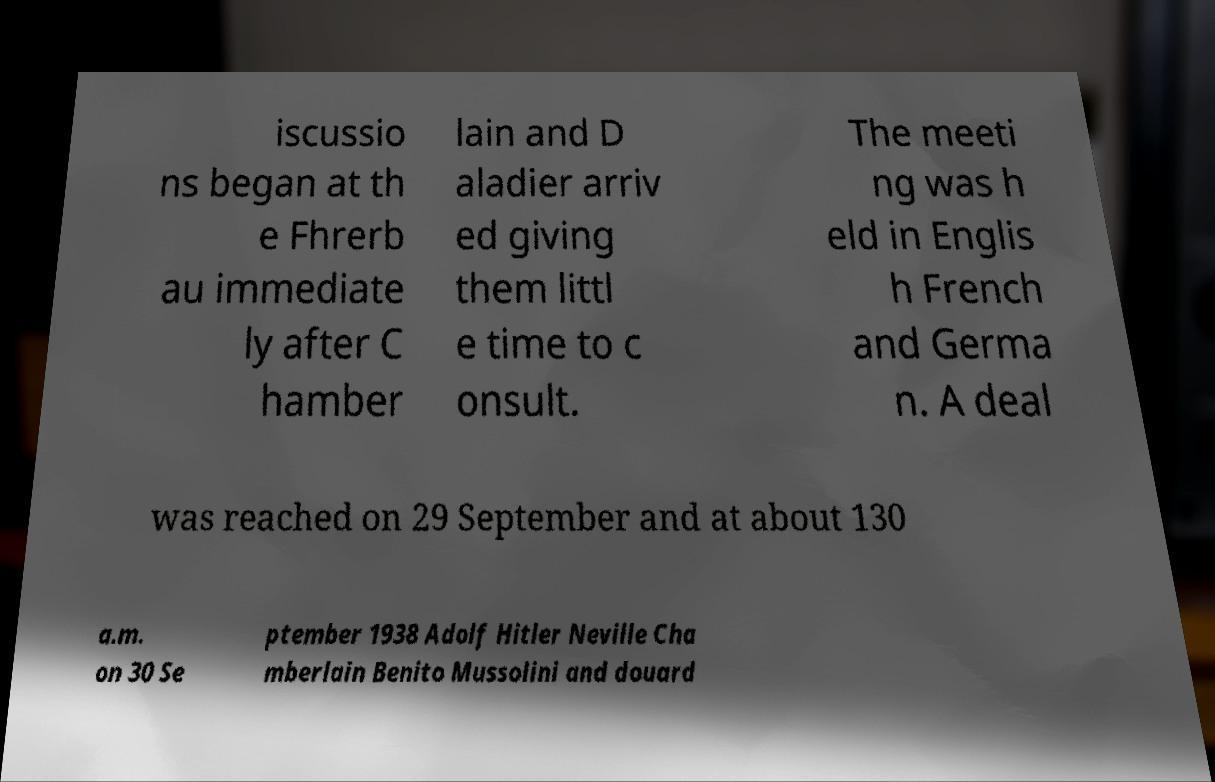Can you accurately transcribe the text from the provided image for me? iscussio ns began at th e Fhrerb au immediate ly after C hamber lain and D aladier arriv ed giving them littl e time to c onsult. The meeti ng was h eld in Englis h French and Germa n. A deal was reached on 29 September and at about 130 a.m. on 30 Se ptember 1938 Adolf Hitler Neville Cha mberlain Benito Mussolini and douard 